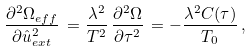<formula> <loc_0><loc_0><loc_500><loc_500>\frac { \partial ^ { 2 } \Omega _ { e f f } } { \partial \hat { u } _ { e x t } ^ { 2 } } \, = \frac { \lambda ^ { 2 } } { T ^ { 2 } } \, \frac { \partial ^ { 2 } \Omega } { \partial \tau ^ { 2 } } \, = - \frac { \lambda ^ { 2 } C ( \tau ) } { T _ { 0 } } \, ,</formula> 